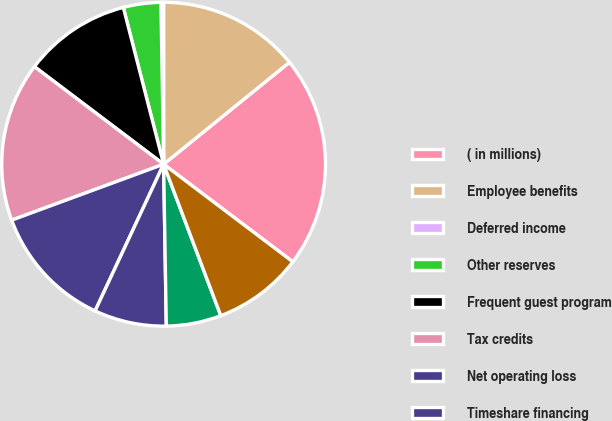Convert chart to OTSL. <chart><loc_0><loc_0><loc_500><loc_500><pie_chart><fcel>( in millions)<fcel>Employee benefits<fcel>Deferred income<fcel>Other reserves<fcel>Frequent guest program<fcel>Tax credits<fcel>Net operating loss<fcel>Timeshare financing<fcel>Property equipment and<fcel>Other net<nl><fcel>21.13%<fcel>14.17%<fcel>0.26%<fcel>3.74%<fcel>10.7%<fcel>15.91%<fcel>12.43%<fcel>7.22%<fcel>5.48%<fcel>8.96%<nl></chart> 